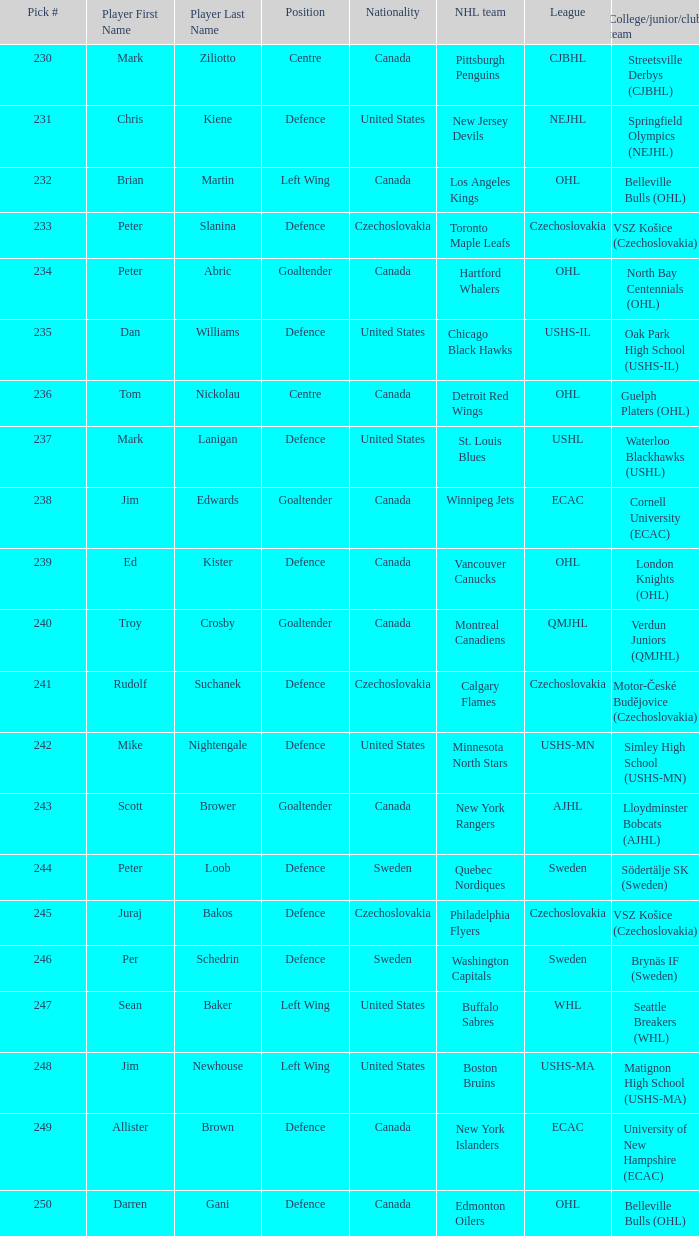To which organziation does the  winnipeg jets belong to? Cornell University (ECAC). 